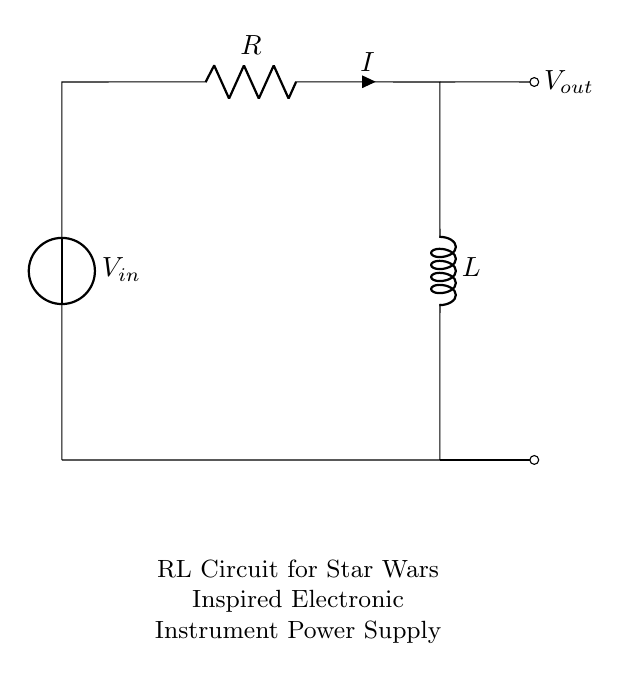What is the input voltage of this circuit? The input voltage, labeled as V_in, is shown as a voltage source in the circuit. It is typically represented with a positive terminal at the top and a negative terminal at the bottom.
Answer: V_in What is the current flowing through the resistor? The current flowing through the resistor is denoted by the label I next to the resistor symbol in the circuit. It indicates the flow of electric charge in the circuit.
Answer: I What components are present in the circuit? The circuit has a voltage source, a resistor, and an inductor. Each component is represented by its symbol and labeled accordingly.
Answer: Voltage source, resistor, inductor How are the resistor and inductor connected in the circuit? The resistor and inductor are connected in series, meaning that they are arranged one after the other in the same path of the circuit, allowing the same current to flow through both components.
Answer: In series What happens to the voltage across the inductor when the current changes? The voltage across the inductor changes in response to the rate of change of current through it, according to Lenz's law. A change in current induces a back EMF that opposes the change.
Answer: It changes with current What type of circuit is this? This is an RL circuit, which is characterized by the presence of a resistor (R) and an inductor (L) in the circuit configuration. RL circuits are used to filter signals and control current flow.
Answer: RL circuit What is the role of the inductor in this RL circuit concerning power supplies? The inductor acts as an energy storage element in the circuit. It smooths the current flow and helps to manage voltage spikes, which is critical for stable power supply in electronic instruments.
Answer: Energy storage 